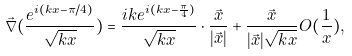<formula> <loc_0><loc_0><loc_500><loc_500>\vec { \nabla } ( \frac { e ^ { i ( k x - \pi / 4 ) } } { \sqrt { k x } } ) = \frac { i k e ^ { i ( k x - \frac { \pi } { 4 } ) } } { \sqrt { k x } } \cdot \frac { \vec { x } } { | \vec { x } | } + { \frac { \vec { x } } { | \vec { x } | \sqrt { k x } } } O ( \frac { 1 } { x } ) ,</formula> 